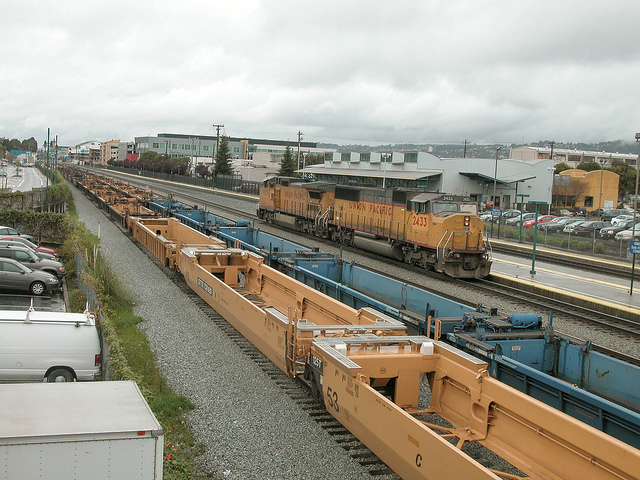<image>Where is this? It is unknown where this is. It can be a train station, rail yard, railroad station, Chicago, or even Russia. Where is this? I don't know where this is. It can be a train station, rail yard, train yard, railroad station, or train depot. 